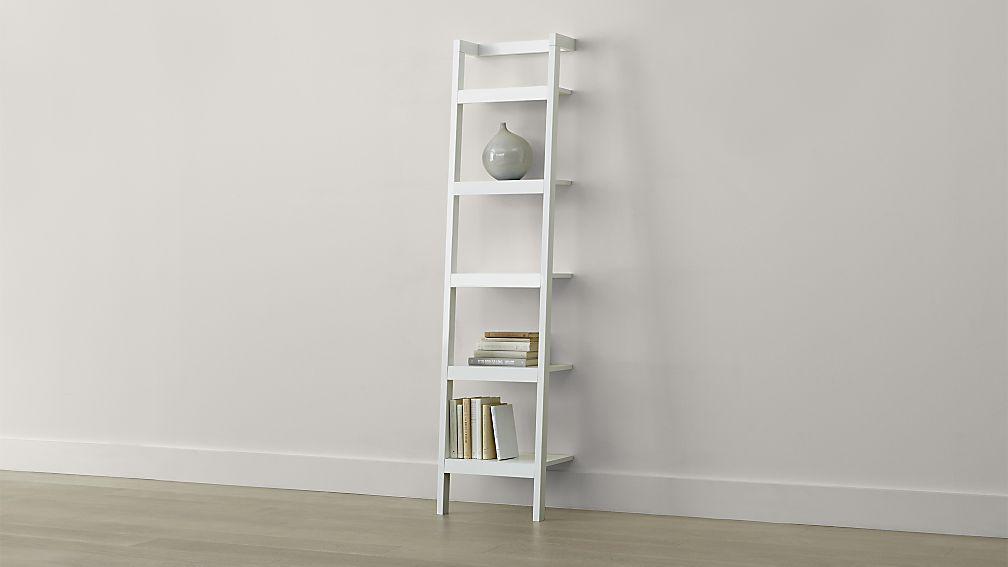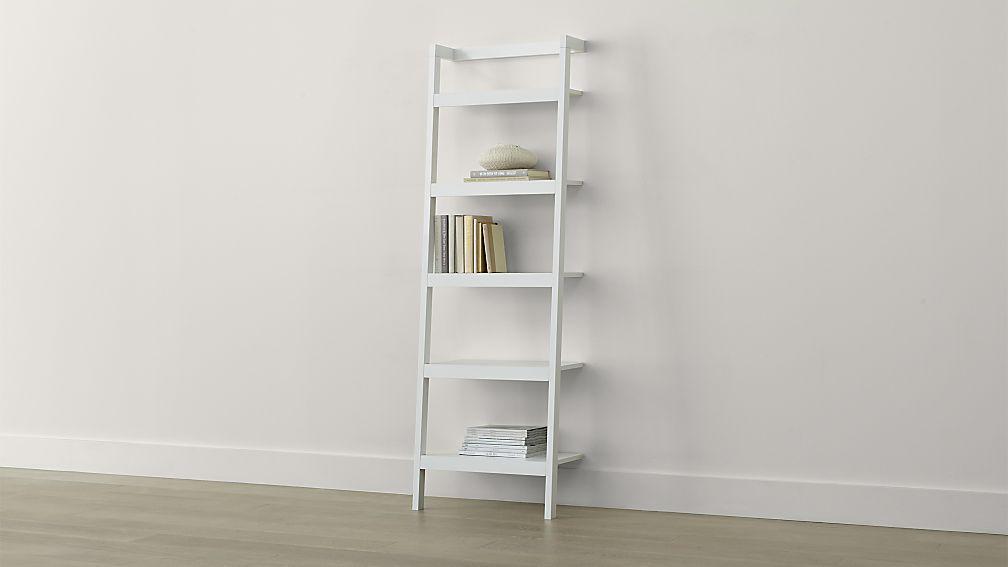The first image is the image on the left, the second image is the image on the right. Given the left and right images, does the statement "The right image features a white bookcase with three vertical rows of shelves, which is backless and leans against a wall." hold true? Answer yes or no. No. The first image is the image on the left, the second image is the image on the right. For the images displayed, is the sentence "The shelf unit in the left image can stand on its own." factually correct? Answer yes or no. No. 